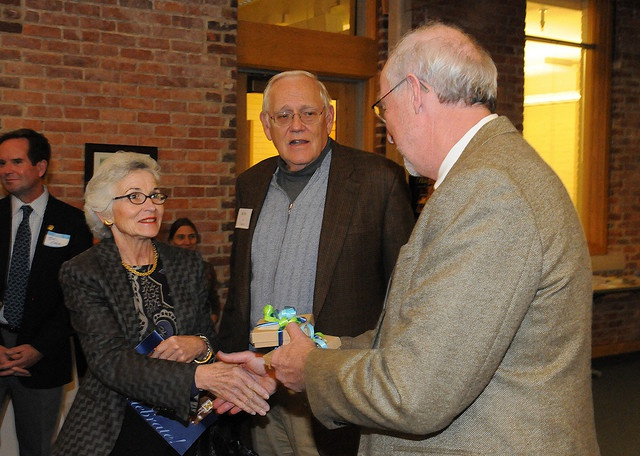Describe the objects in this image and their specific colors. I can see people in maroon, gray, and darkgray tones, people in maroon, black, gray, tan, and salmon tones, people in maroon, black, gray, and salmon tones, people in maroon, black, gray, and brown tones, and tie in maroon, black, and gray tones in this image. 